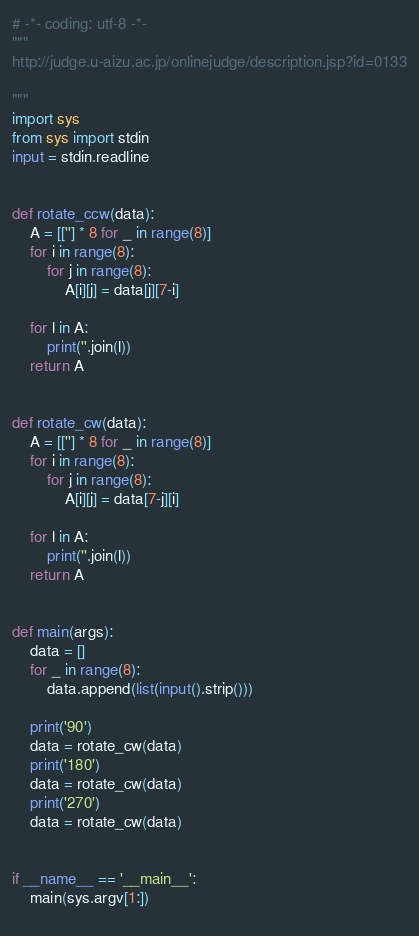<code> <loc_0><loc_0><loc_500><loc_500><_Python_># -*- coding: utf-8 -*-
"""
http://judge.u-aizu.ac.jp/onlinejudge/description.jsp?id=0133

"""
import sys
from sys import stdin
input = stdin.readline


def rotate_ccw(data):
    A = [[''] * 8 for _ in range(8)]
    for i in range(8):
        for j in range(8):
            A[i][j] = data[j][7-i]

    for l in A:
        print(''.join(l))
    return A


def rotate_cw(data):
    A = [[''] * 8 for _ in range(8)]
    for i in range(8):
        for j in range(8):
            A[i][j] = data[7-j][i]

    for l in A:
        print(''.join(l))
    return A


def main(args):
    data = []
    for _ in range(8):
        data.append(list(input().strip()))

    print('90')
    data = rotate_cw(data)
    print('180')
    data = rotate_cw(data)
    print('270')
    data = rotate_cw(data)


if __name__ == '__main__':
    main(sys.argv[1:])
    </code> 